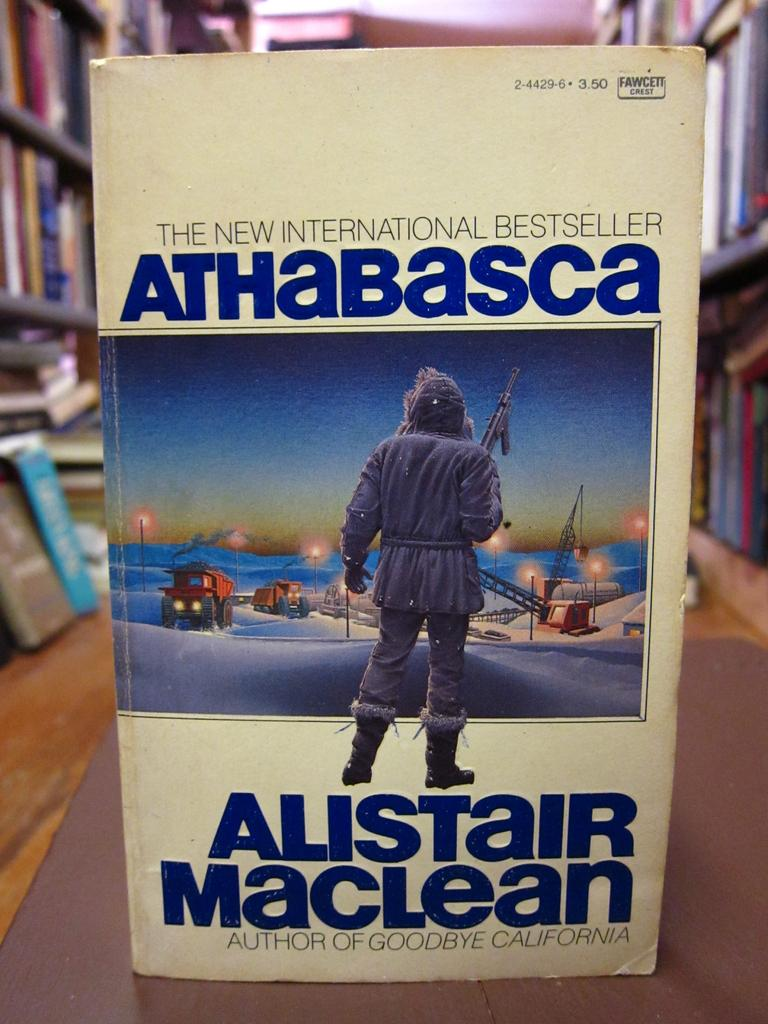<image>
Write a terse but informative summary of the picture. A book which is by Alistair Maclean and has a man on the cover. 